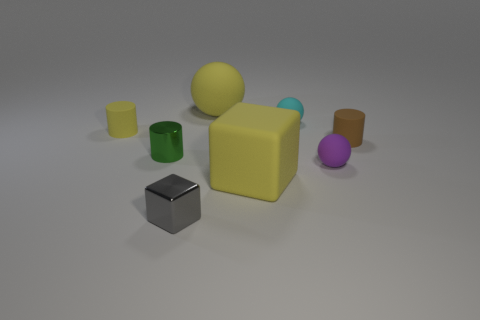Add 1 small cyan cylinders. How many objects exist? 9 Subtract all blocks. How many objects are left? 6 Subtract 1 yellow blocks. How many objects are left? 7 Subtract all big yellow shiny things. Subtract all cylinders. How many objects are left? 5 Add 5 small green metal cylinders. How many small green metal cylinders are left? 6 Add 7 purple balls. How many purple balls exist? 8 